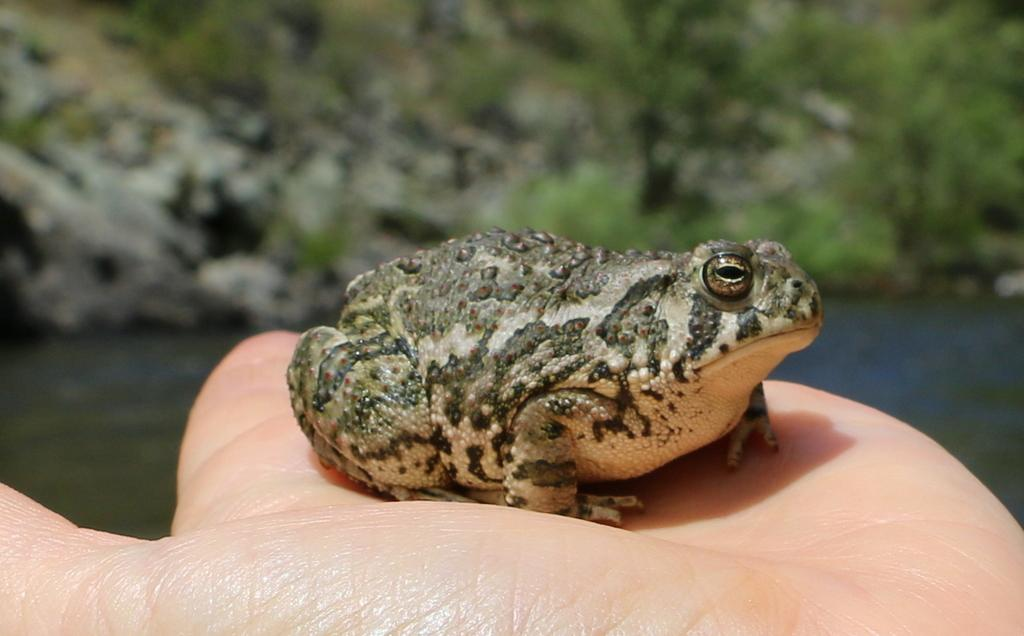What animal is in the image? There is a frog in the image. Where is the frog located? The frog is on a person's hand. What can be seen in the background of the image? There are hills, trees, and water visible in the background of the image. What type of lead is the frog using to communicate with the person in the image? There is no indication in the image that the frog is using any type of lead to communicate with the person. 